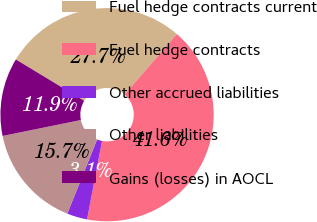<chart> <loc_0><loc_0><loc_500><loc_500><pie_chart><fcel>Fuel hedge contracts current<fcel>Fuel hedge contracts<fcel>Other accrued liabilities<fcel>Other liabilities<fcel>Gains (losses) in AOCL<nl><fcel>27.7%<fcel>41.64%<fcel>3.08%<fcel>15.72%<fcel>11.86%<nl></chart> 